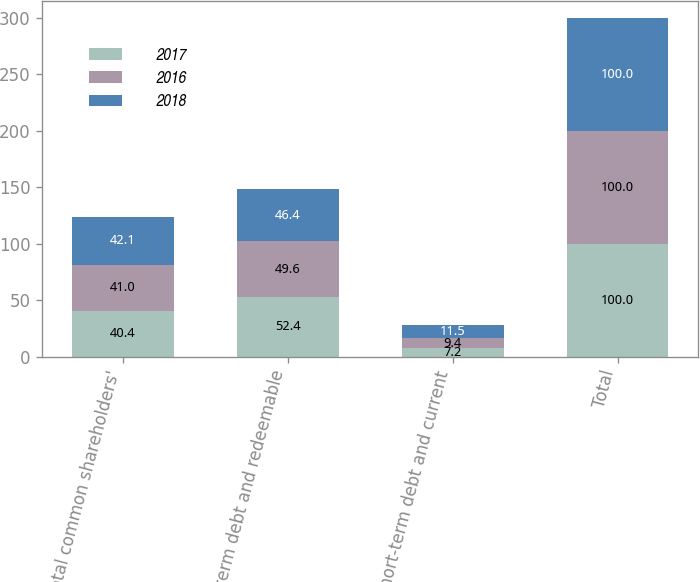<chart> <loc_0><loc_0><loc_500><loc_500><stacked_bar_chart><ecel><fcel>Total common shareholders'<fcel>Long-term debt and redeemable<fcel>Short-term debt and current<fcel>Total<nl><fcel>2017<fcel>40.4<fcel>52.4<fcel>7.2<fcel>100<nl><fcel>2016<fcel>41<fcel>49.6<fcel>9.4<fcel>100<nl><fcel>2018<fcel>42.1<fcel>46.4<fcel>11.5<fcel>100<nl></chart> 